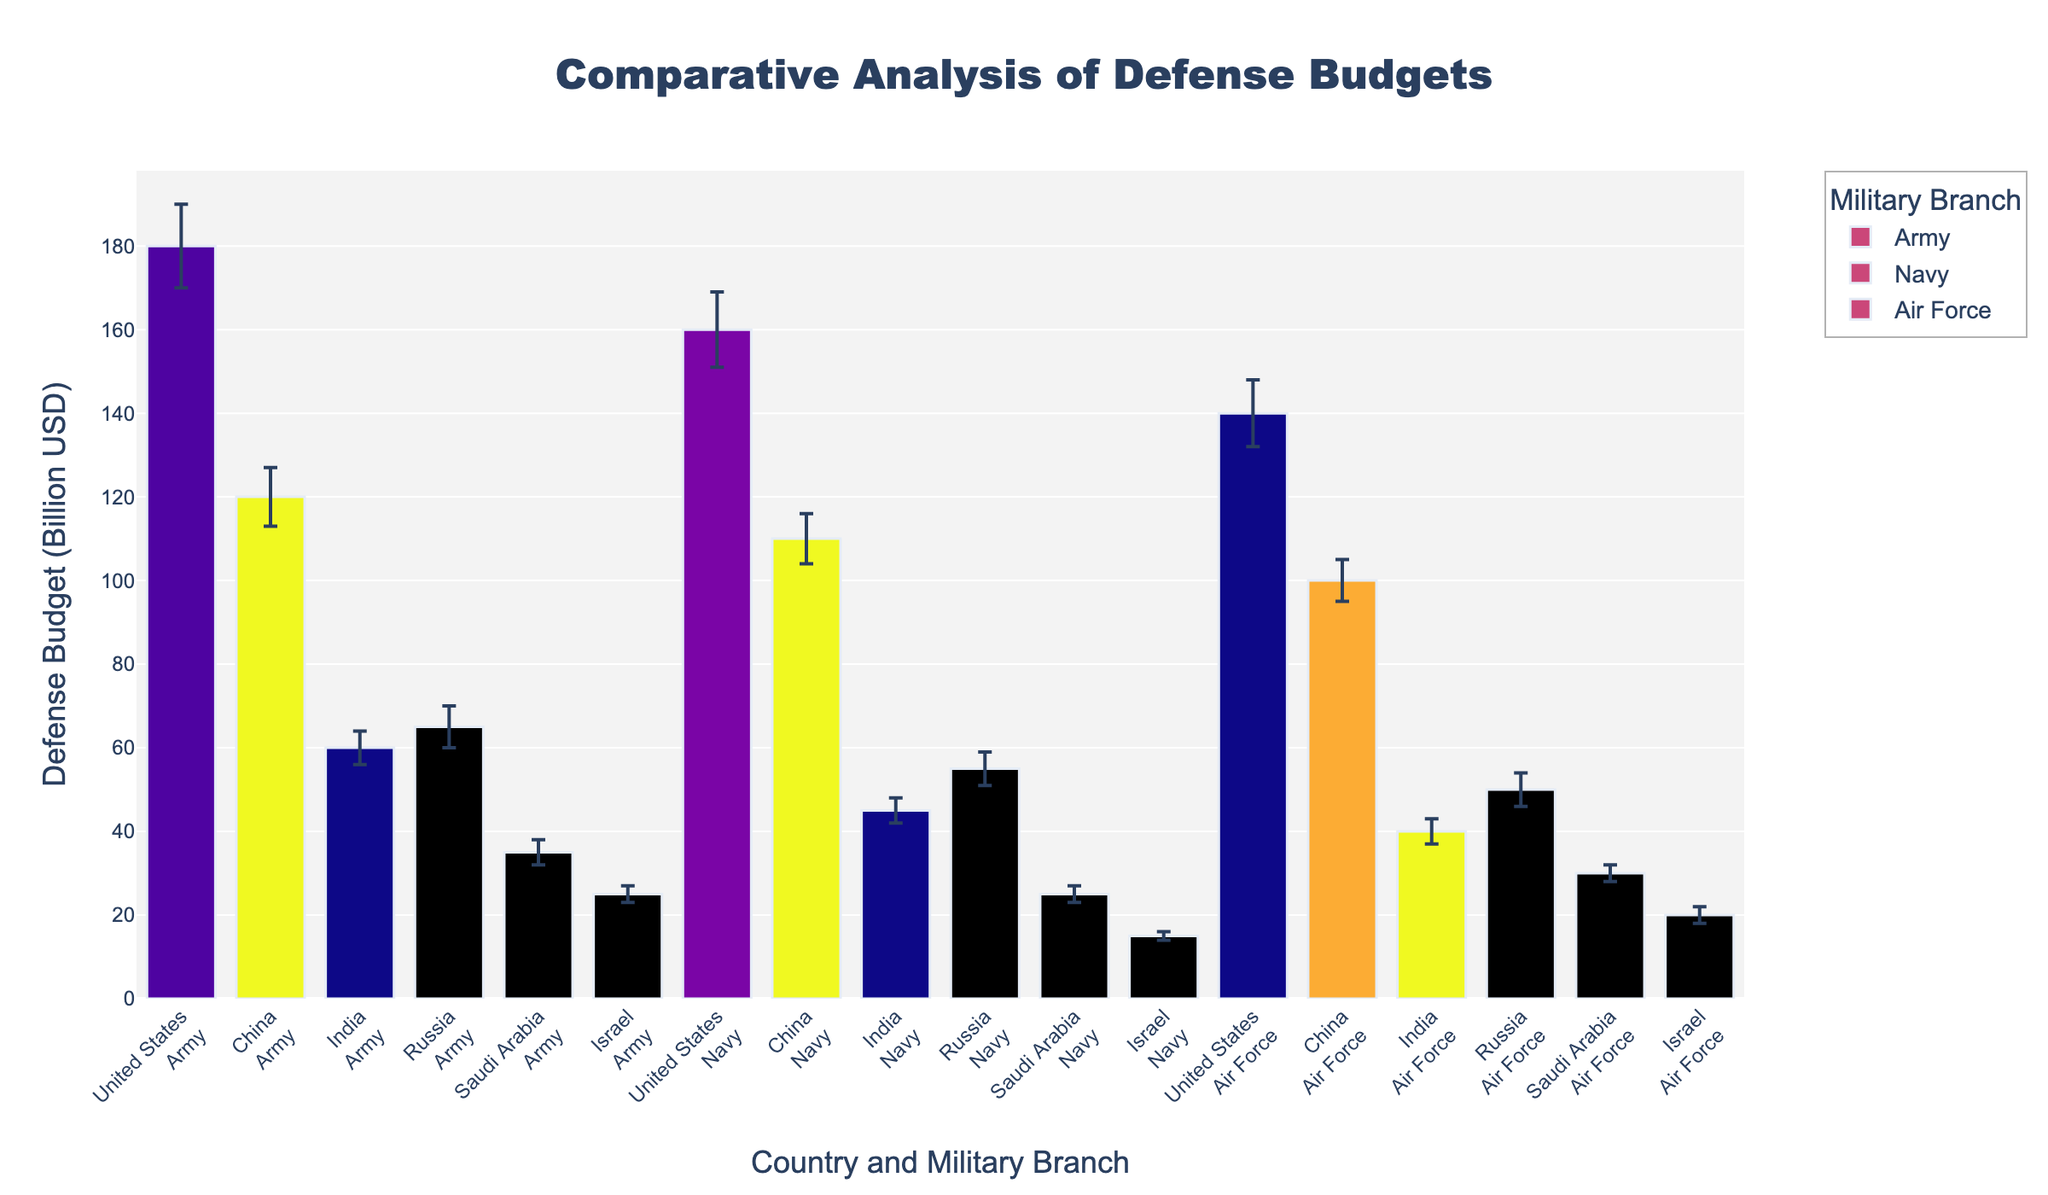What's the title of the figure? The title is located at the top of the figure and summarizes the overall subject of the visualization.
Answer: Comparative Analysis of Defense Budgets Which country has the highest defense budget for the Navy? By examining the height of the bars under the "Navy" category for each country, we can see that the bar for the United States' Navy is the tallest.
Answer: United States What is the error margin for China's Air Force budget? The error margin is indicated by the error bars. For China's Air Force, the error bar size is 5 billion USD.
Answer: 5 billion USD Which country's Army defense budget is closest to Russia's Army defense budget? By comparing the height of the bars, we see that Saudi Arabia's Army budget is closest to Russia's Army budget.
Answer: Saudi Arabia What's the combined defense budget of India's Navy and Air Force? India's Navy budget is 45 billion USD and Air Force budget is 40 billion USD. Combining these, 45 + 40 = 85 billion USD.
Answer: 85 billion USD Which country shows the smallest variation in defense budgets across its military branches? The variation is indicated by the difference in bar heights for each branch. Israel has the smallest difference among its Army, Navy, and Air Force budgets.
Answer: Israel How does the United States' Navy budget compare to China's total defense budget for all branches? The United States' Navy budget is 160 billion USD. China's total defense budget across all branches is 120 + 110 + 100 = 330 billion USD, which is more than the U.S. Navy's budget.
Answer: Less than China's total What's the total defense budget for Saudi Arabia? Summing up Saudi Arabia's budgets: Army (35 billion USD), Navy (25 billion USD), Air Force (30 billion USD) yields a total of 35 + 25 + 30 = 90 billion USD.
Answer: 90 billion USD Which country has the largest budget allocation for its Air Force, and what is the amount? By examining the heights of the bars under "Air Force," the United States has the tallest bar, representing 140 billion USD.
Answer: United States, 140 billion USD How does India's defense budget for its Navy compare to Israel's total defense budget? India's Navy budget is 45 billion USD. Israel's total defense budget is 25 + 15 + 20 = 60 billion USD, which is higher than India's Navy budget.
Answer: Less than Israel's total 